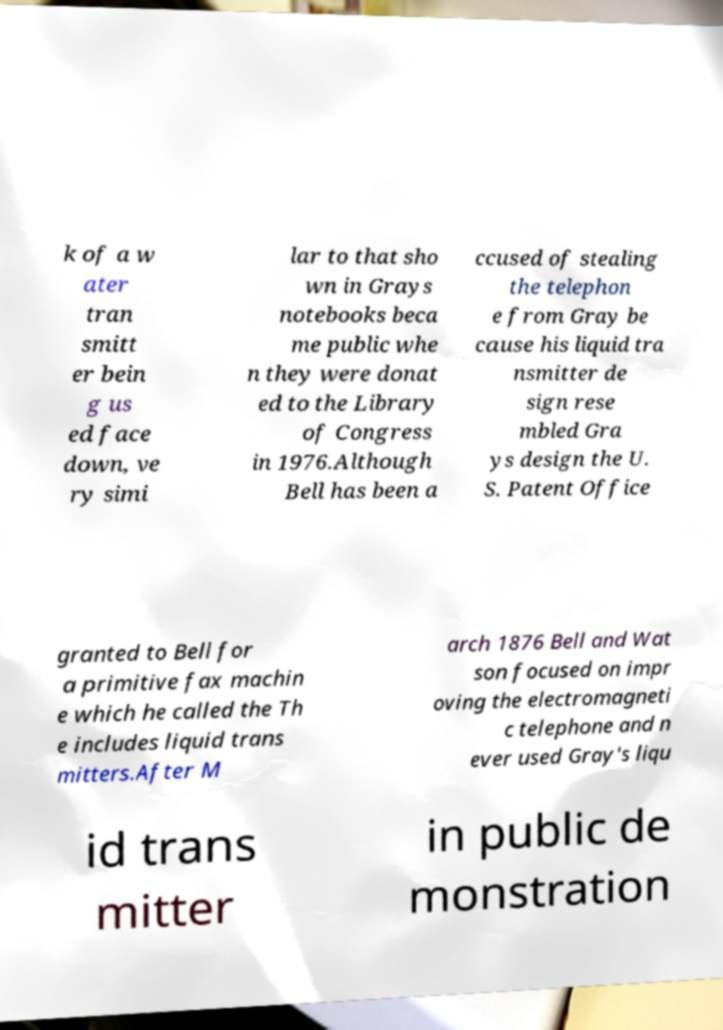Please identify and transcribe the text found in this image. k of a w ater tran smitt er bein g us ed face down, ve ry simi lar to that sho wn in Grays notebooks beca me public whe n they were donat ed to the Library of Congress in 1976.Although Bell has been a ccused of stealing the telephon e from Gray be cause his liquid tra nsmitter de sign rese mbled Gra ys design the U. S. Patent Office granted to Bell for a primitive fax machin e which he called the Th e includes liquid trans mitters.After M arch 1876 Bell and Wat son focused on impr oving the electromagneti c telephone and n ever used Gray's liqu id trans mitter in public de monstration 